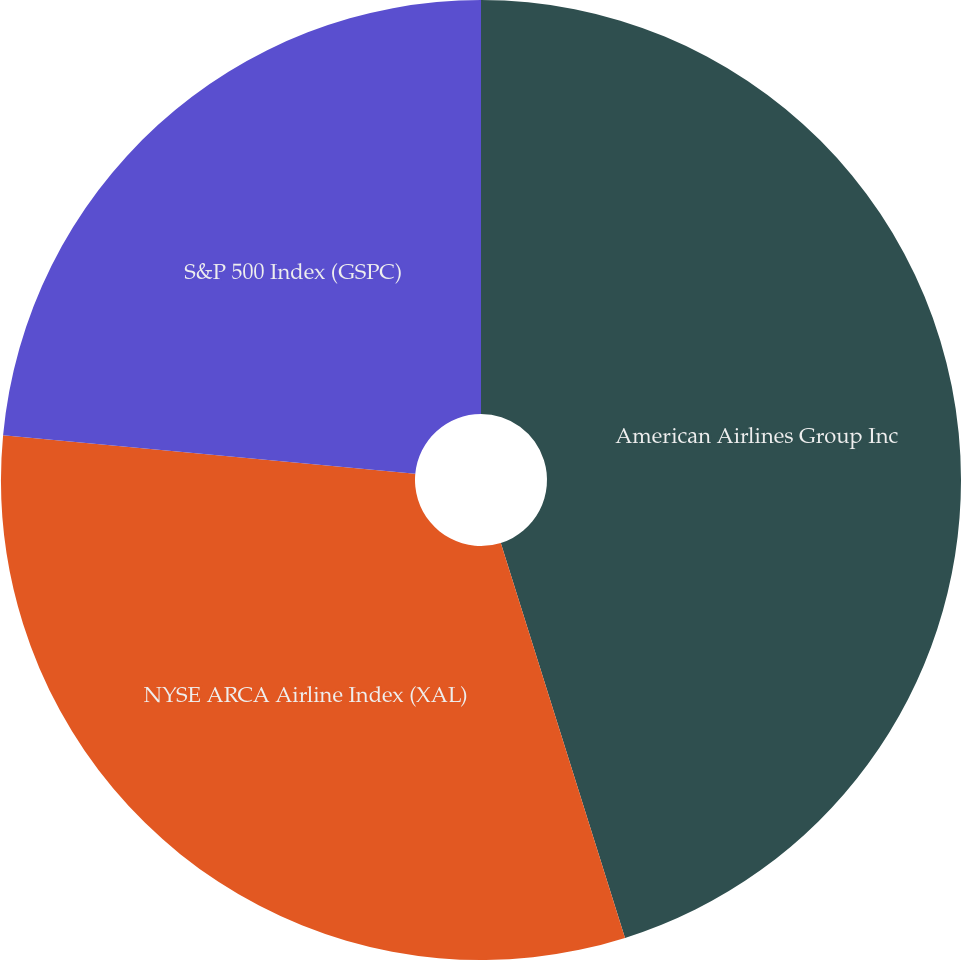<chart> <loc_0><loc_0><loc_500><loc_500><pie_chart><fcel>American Airlines Group Inc<fcel>NYSE ARCA Airline Index (XAL)<fcel>S&P 500 Index (GSPC)<nl><fcel>45.15%<fcel>31.34%<fcel>23.51%<nl></chart> 